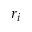<formula> <loc_0><loc_0><loc_500><loc_500>r _ { i }</formula> 